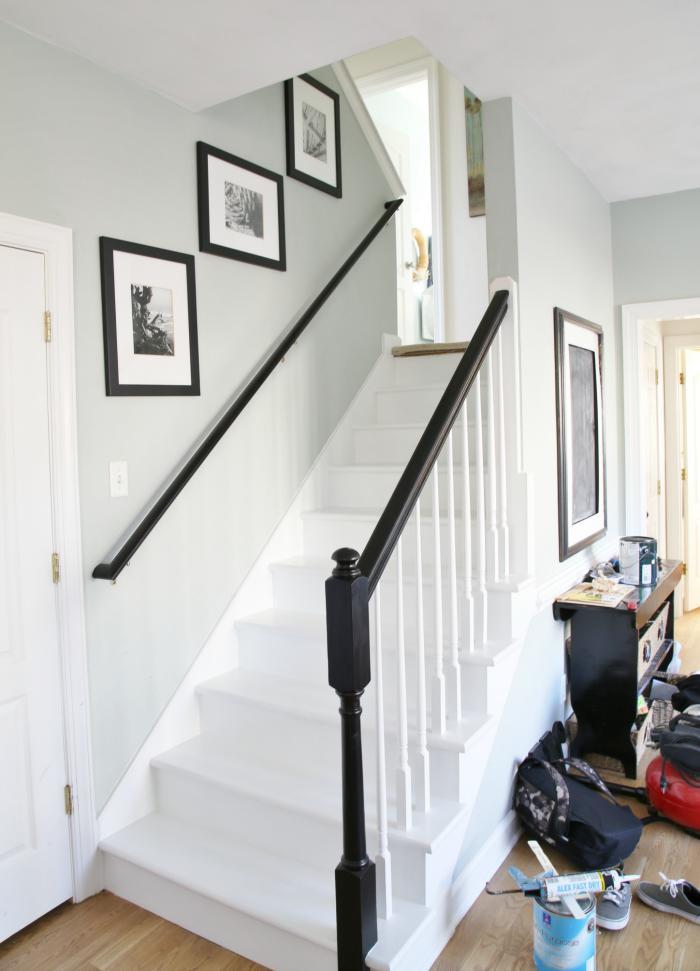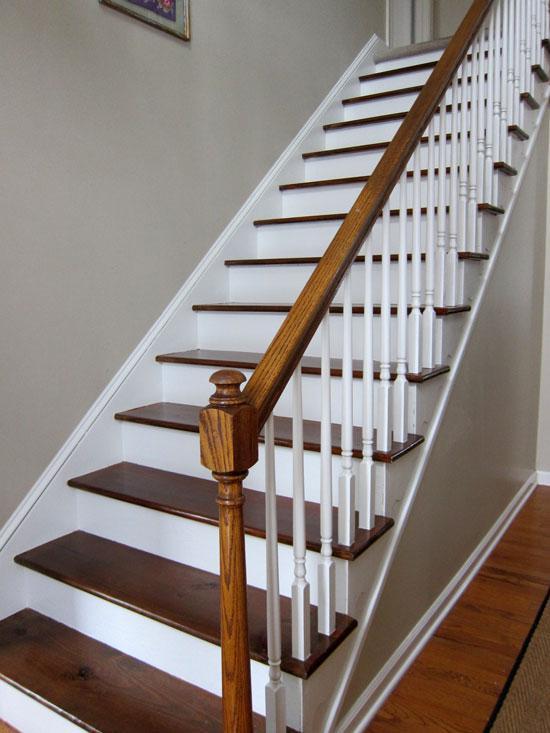The first image is the image on the left, the second image is the image on the right. Analyze the images presented: Is the assertion "One stairway changes direction." valid? Answer yes or no. Yes. 